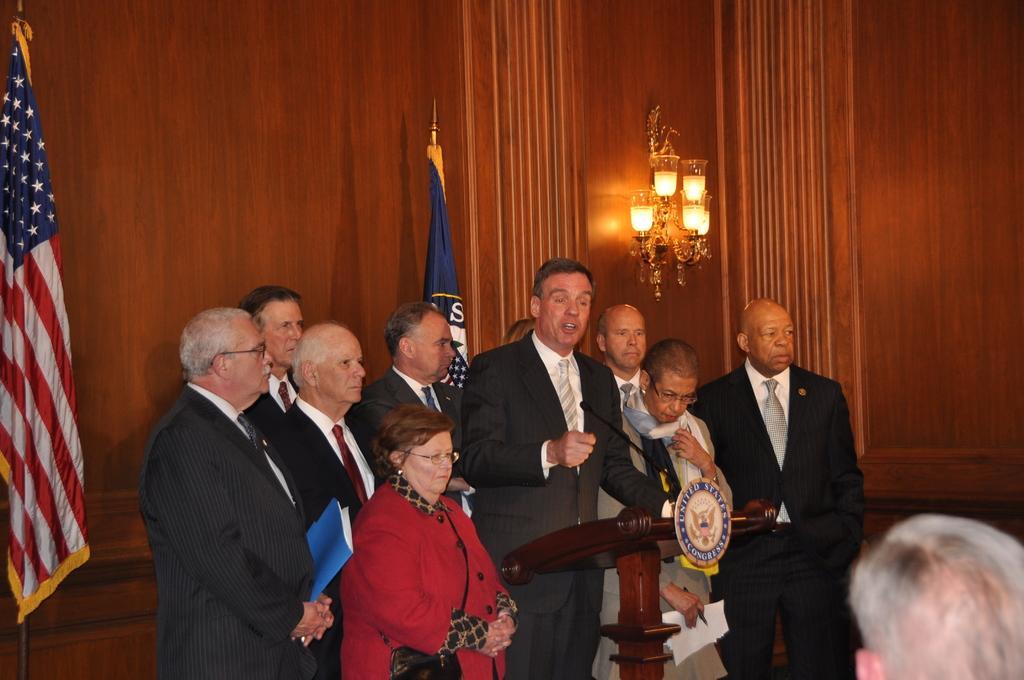Can you describe this image briefly? In the center of the image we can see many person standing on the ground. In the background we can see flags, wall and lights. 